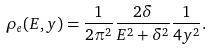<formula> <loc_0><loc_0><loc_500><loc_500>\rho _ { e } ( E , y ) = \frac { 1 } { 2 \pi ^ { 2 } } \frac { 2 \delta } { E ^ { 2 } + \delta ^ { 2 } } \frac { 1 } { 4 y ^ { 2 } } .</formula> 